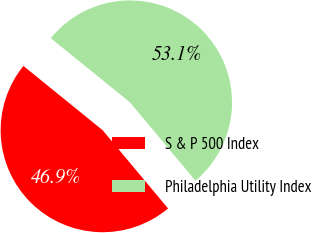Convert chart to OTSL. <chart><loc_0><loc_0><loc_500><loc_500><pie_chart><fcel>S & P 500 Index<fcel>Philadelphia Utility Index<nl><fcel>46.93%<fcel>53.07%<nl></chart> 